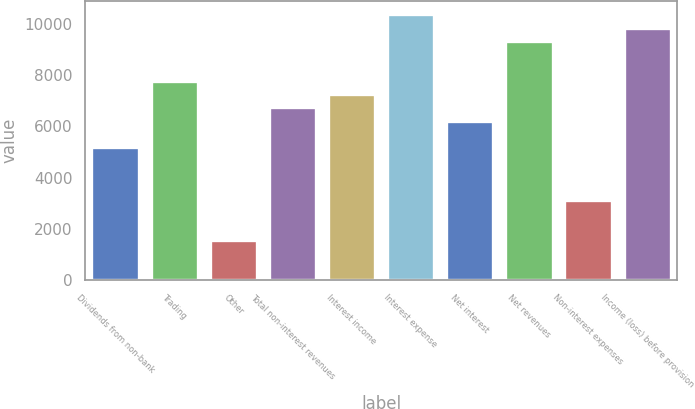Convert chart. <chart><loc_0><loc_0><loc_500><loc_500><bar_chart><fcel>Dividends from non-bank<fcel>Trading<fcel>Other<fcel>Total non-interest revenues<fcel>Interest income<fcel>Interest expense<fcel>Net interest<fcel>Net revenues<fcel>Non-interest expenses<fcel>Income (loss) before provision<nl><fcel>5190<fcel>7782<fcel>1561.2<fcel>6745.2<fcel>7263.6<fcel>10374<fcel>6226.8<fcel>9337.2<fcel>3116.4<fcel>9855.6<nl></chart> 